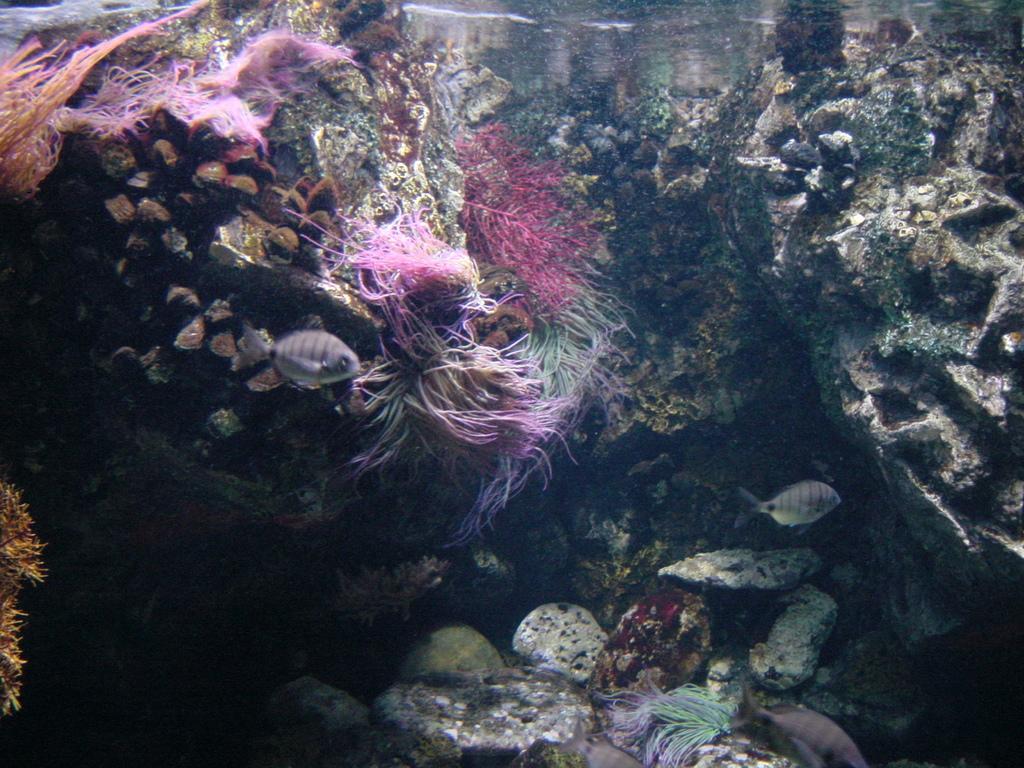Please provide a concise description of this image. As we can see in the image there are rocks, water and fishes. 